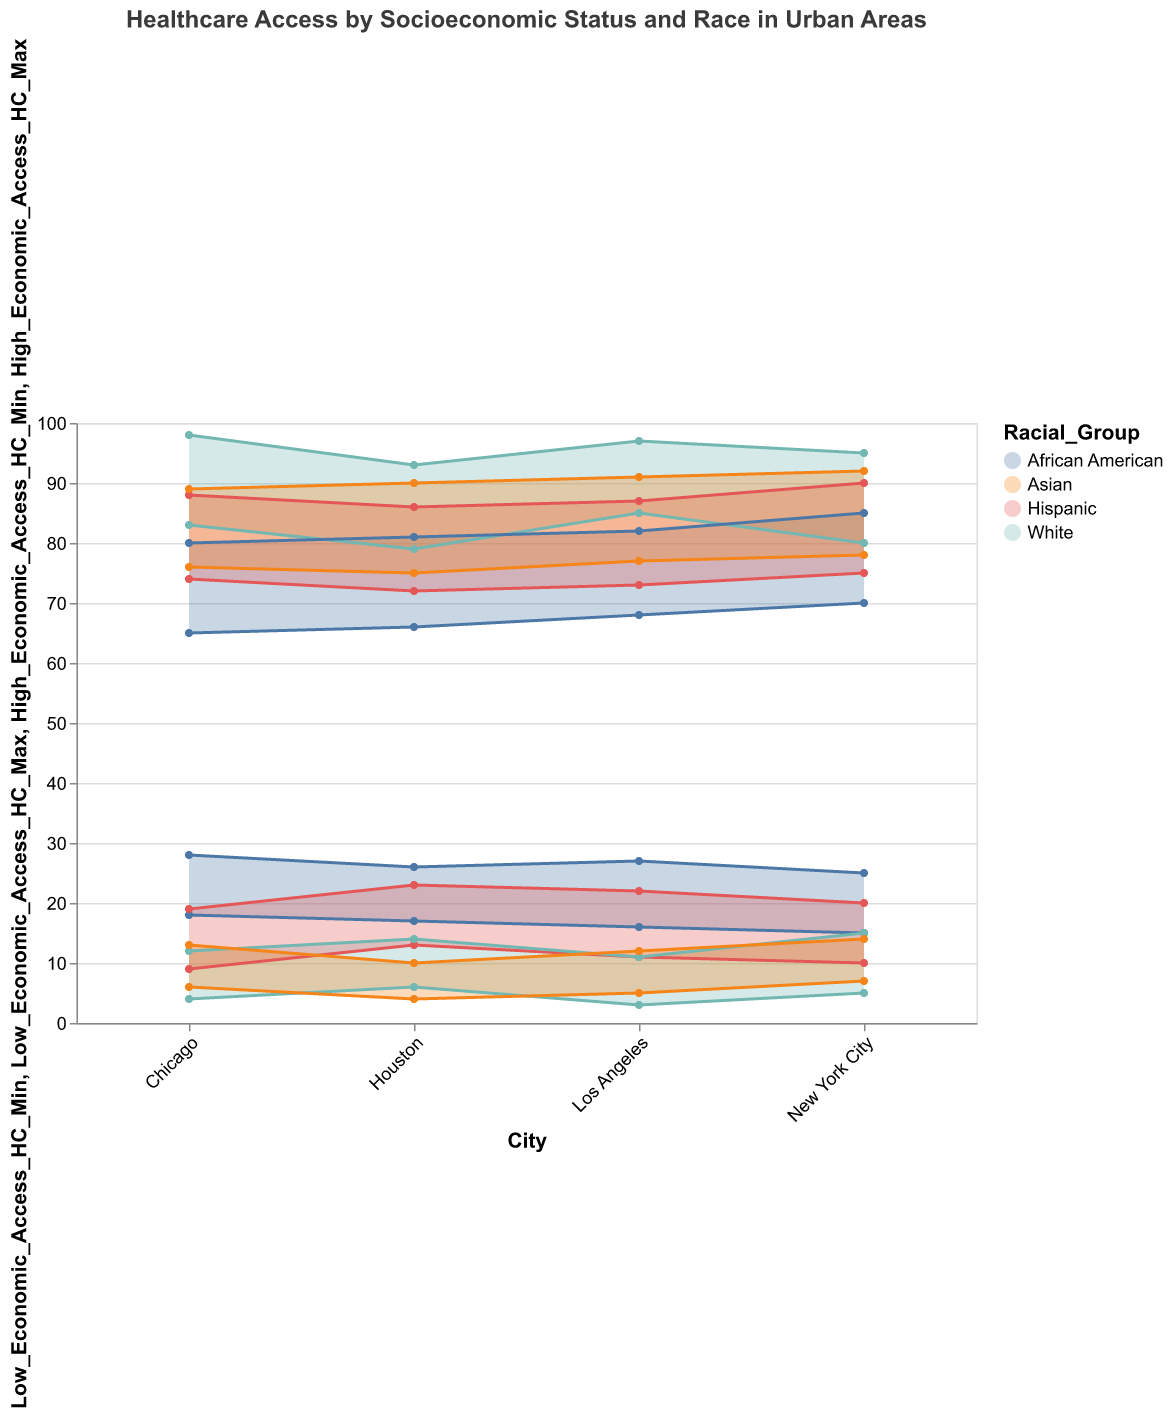What's the title of the figure? The title of the figure is displayed at the top.
Answer: Healthcare Access by Socioeconomic Status and Race in Urban Areas What are the racial groups represented in the figure? The legend to the right of the figure identifies the different racial groups. They are African American, White, Hispanic, and Asian.
Answer: African American, White, Hispanic, Asian In which city do African Americans with low economic status have the highest maximum access to healthcare? By examining the 'Low_Economic_Access_HC_Max' values for African Americans across all cities, we see that New York City has the highest value.
Answer: New York City Which racial group has the lowest minimum access to healthcare for those in high economic status in Los Angeles? Look at the 'High_Economic_Access_HC_Min' values for each racial group in Los Angeles. The White group has the highest values, while Asians have the lowest.
Answer: Asian Compare the range of healthcare access for African Americans with low economic status between Chicago and Houston. In Chicago, the range is from 18 to 28. In Houston, it is from 17 to 26. Calculating both ranges (28-18) and (26-17), Chicago has a broader range.
Answer: Chicago Which city has the widest range of healthcare access for Asians in high economic status? Calculate the differential between 'High_Economic_Access_HC_Max' and 'High_Economic_Access_HC_Min' for Asians across all cities. New York City has a range of 14, Chicago has 13, Los Angeles has 14, and Houston has 15. Houston has the widest range.
Answer: Houston What is the average maximum healthcare access for Whites with high economic status across all cities? Add up the maximum access values (95 + 98 + 97 + 93) and divide by the number of cities (4). The calculation is (95 + 98 + 97 + 93)/4 = 95.75.
Answer: 95.75 For Hispanics in New York City, what is the difference between their maximum access in high economic status and low economic status? Subtract 'Low_Economic_Access_HC_Max' (20) from 'High_Economic_Access_HC_Max' (90). The calculation is 90 - 20 = 70.
Answer: 70 In which city do Whites have the highest minimum access to healthcare for both low and high economic statuses? Compare 'Low_Economic_Access_HC_Min' and 'High_Economic_Access_HC_Min' for Whites across all cities. The highest values are in Los Angeles, with 3 and 85 respectively. The minimum access is the highest overall in Chicago.
Answer: Chicago 